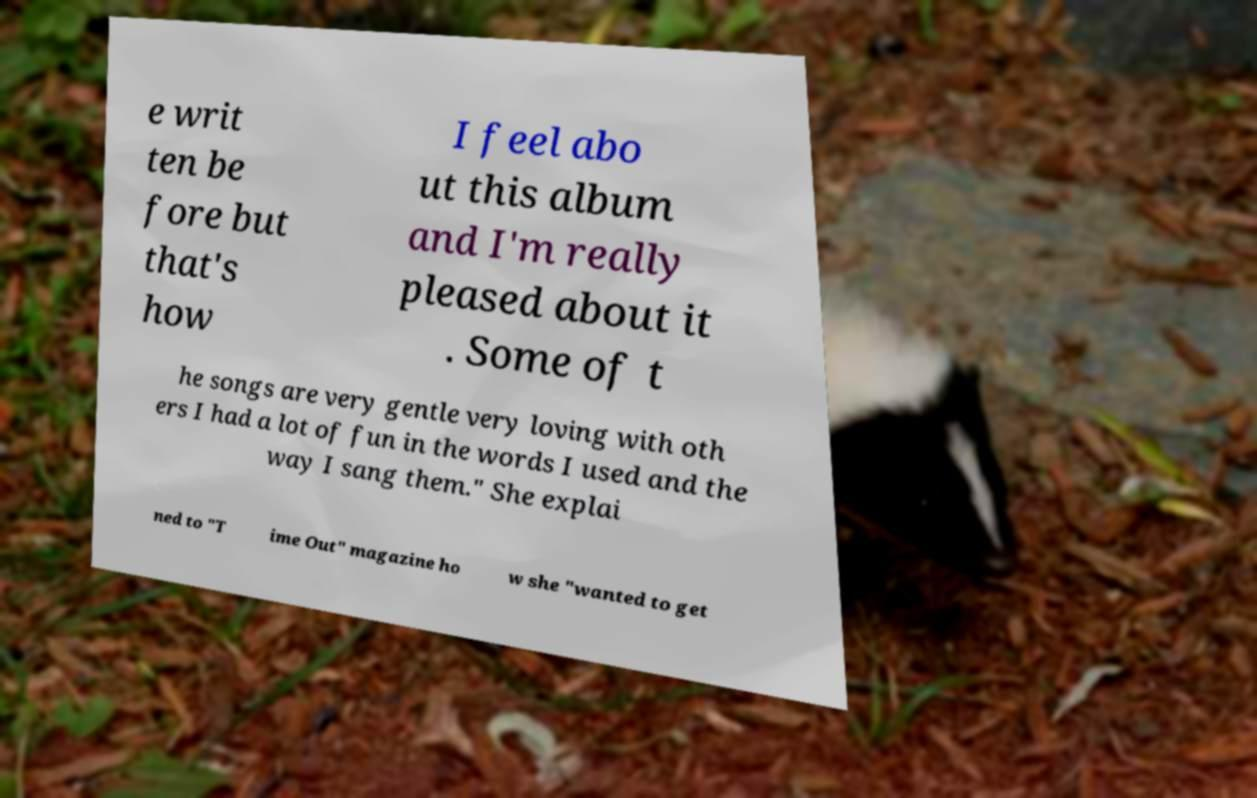What messages or text are displayed in this image? I need them in a readable, typed format. e writ ten be fore but that's how I feel abo ut this album and I'm really pleased about it . Some of t he songs are very gentle very loving with oth ers I had a lot of fun in the words I used and the way I sang them." She explai ned to "T ime Out" magazine ho w she "wanted to get 